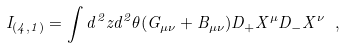Convert formula to latex. <formula><loc_0><loc_0><loc_500><loc_500>I _ { ( 4 , 1 ) } = \int d ^ { 2 } z d ^ { 2 } \theta ( G _ { \mu \nu } + B _ { \mu \nu } ) D _ { + } X ^ { \mu } D _ { - } X ^ { \nu } \ ,</formula> 